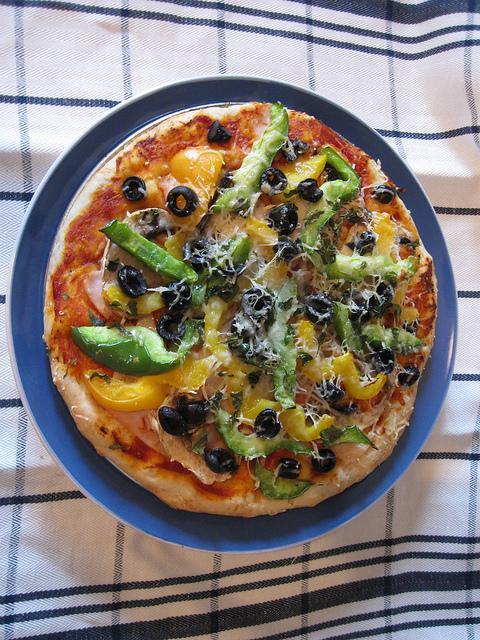Is the pizza cut into slices?
Keep it brief. No. What design does the tablecloth have?
Quick response, please. Plaid. Is the pizza eaten?
Give a very brief answer. No. Is the pizza vegetarian-friendly?
Be succinct. Yes. 